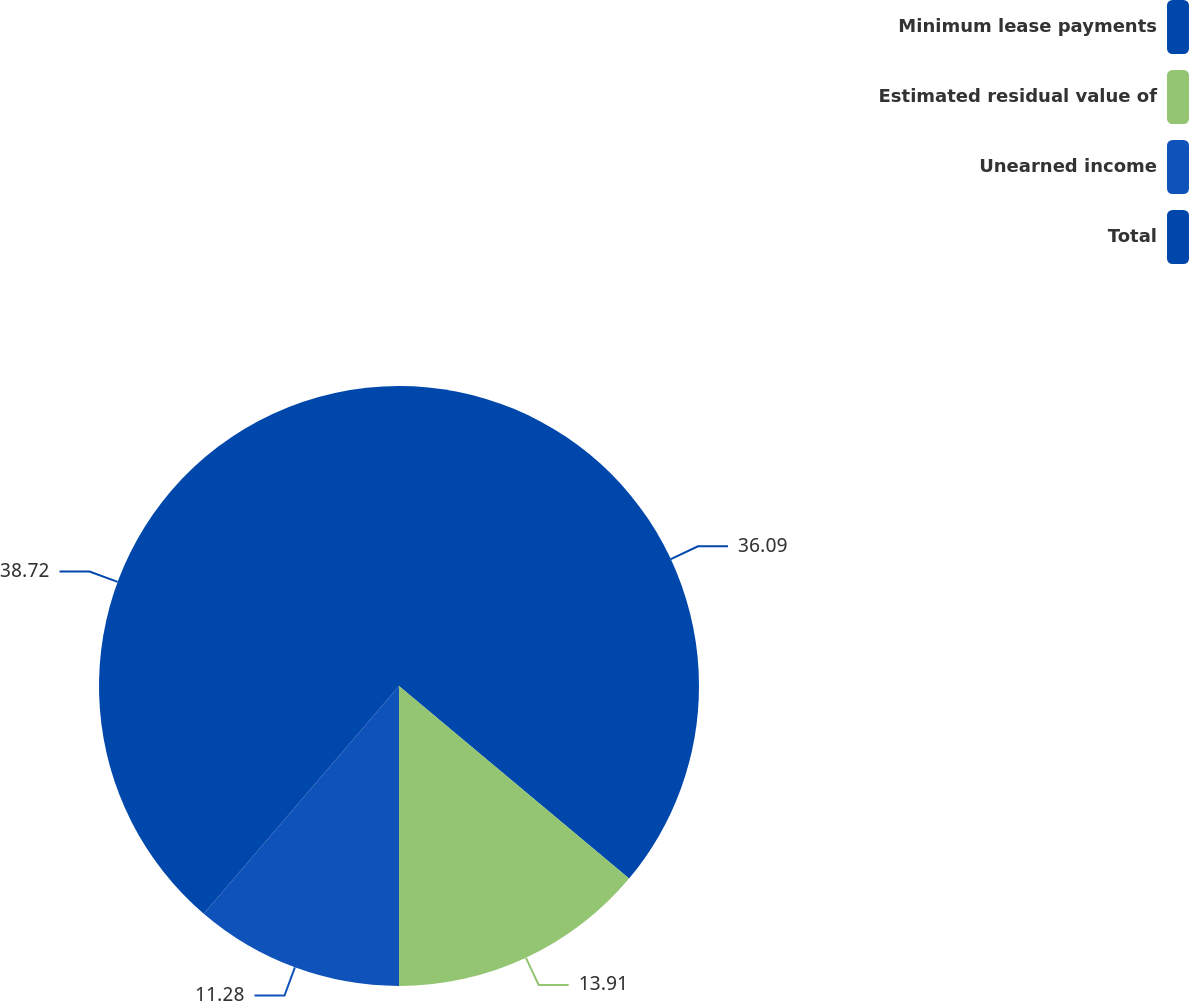<chart> <loc_0><loc_0><loc_500><loc_500><pie_chart><fcel>Minimum lease payments<fcel>Estimated residual value of<fcel>Unearned income<fcel>Total<nl><fcel>36.09%<fcel>13.91%<fcel>11.28%<fcel>38.72%<nl></chart> 